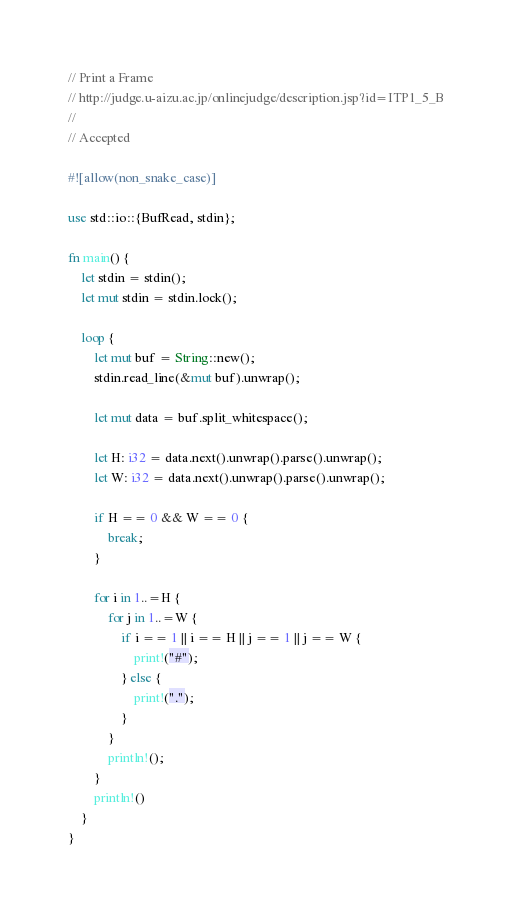Convert code to text. <code><loc_0><loc_0><loc_500><loc_500><_Rust_>// Print a Frame
// http://judge.u-aizu.ac.jp/onlinejudge/description.jsp?id=ITP1_5_B
//
// Accepted

#![allow(non_snake_case)]

use std::io::{BufRead, stdin};

fn main() {
    let stdin = stdin();
    let mut stdin = stdin.lock();

    loop {
        let mut buf = String::new();
        stdin.read_line(&mut buf).unwrap();

        let mut data = buf.split_whitespace();

        let H: i32 = data.next().unwrap().parse().unwrap();
        let W: i32 = data.next().unwrap().parse().unwrap();

        if H == 0 && W == 0 {
            break;
        }

        for i in 1..=H {
            for j in 1..=W {
                if i == 1 || i == H || j == 1 || j == W {
                    print!("#");
                } else {
                    print!(".");
                }
            }
            println!();
        }
        println!()
    }
}
</code> 